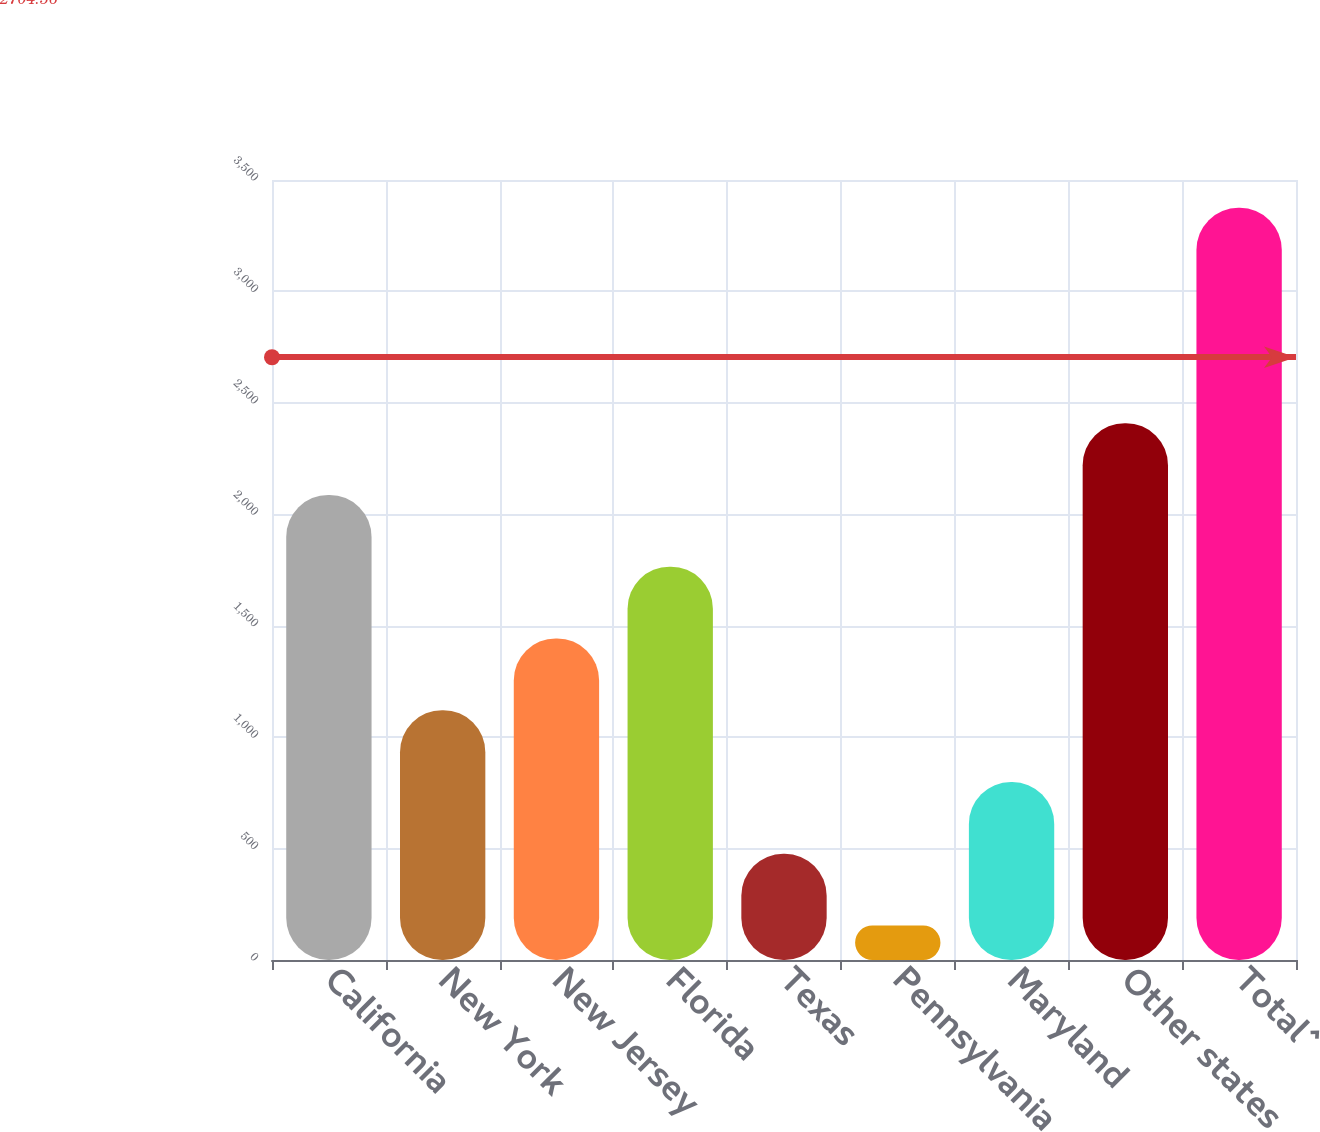<chart> <loc_0><loc_0><loc_500><loc_500><bar_chart><fcel>California<fcel>New York<fcel>New Jersey<fcel>Florida<fcel>Texas<fcel>Pennsylvania<fcel>Maryland<fcel>Other states<fcel>Total^<nl><fcel>2087<fcel>1121<fcel>1443<fcel>1765<fcel>477<fcel>155<fcel>799<fcel>2409<fcel>3375<nl></chart> 